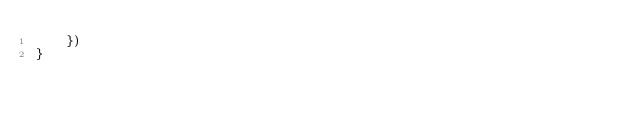<code> <loc_0><loc_0><loc_500><loc_500><_JavaScript_>    })
}</code> 